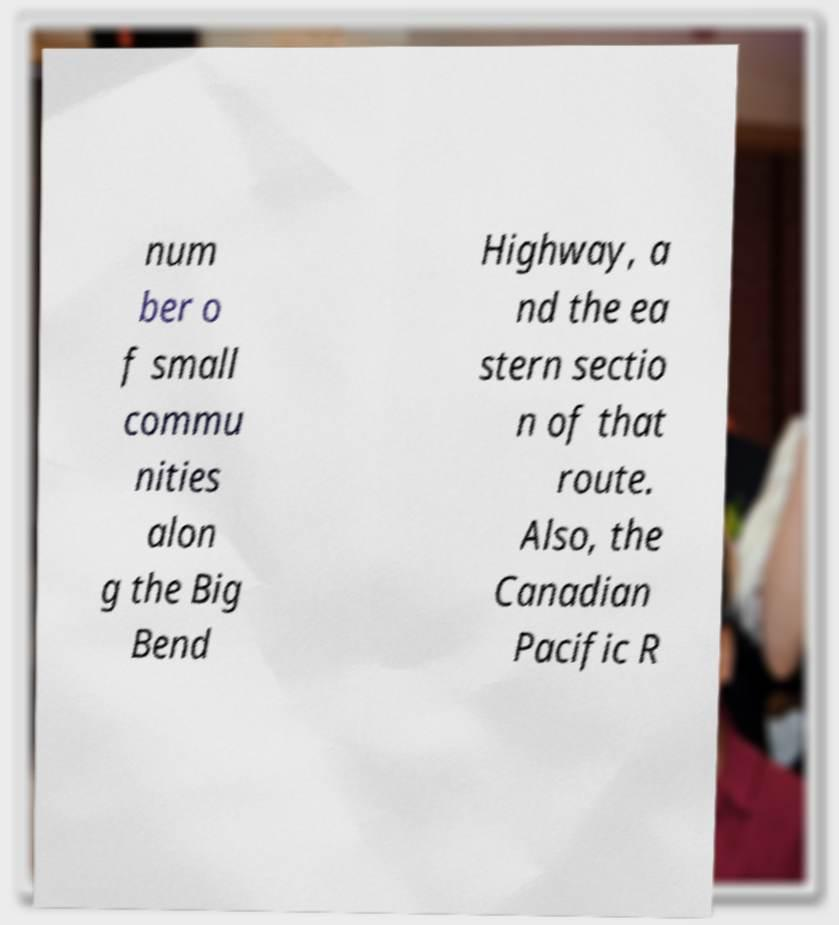Can you read and provide the text displayed in the image?This photo seems to have some interesting text. Can you extract and type it out for me? num ber o f small commu nities alon g the Big Bend Highway, a nd the ea stern sectio n of that route. Also, the Canadian Pacific R 